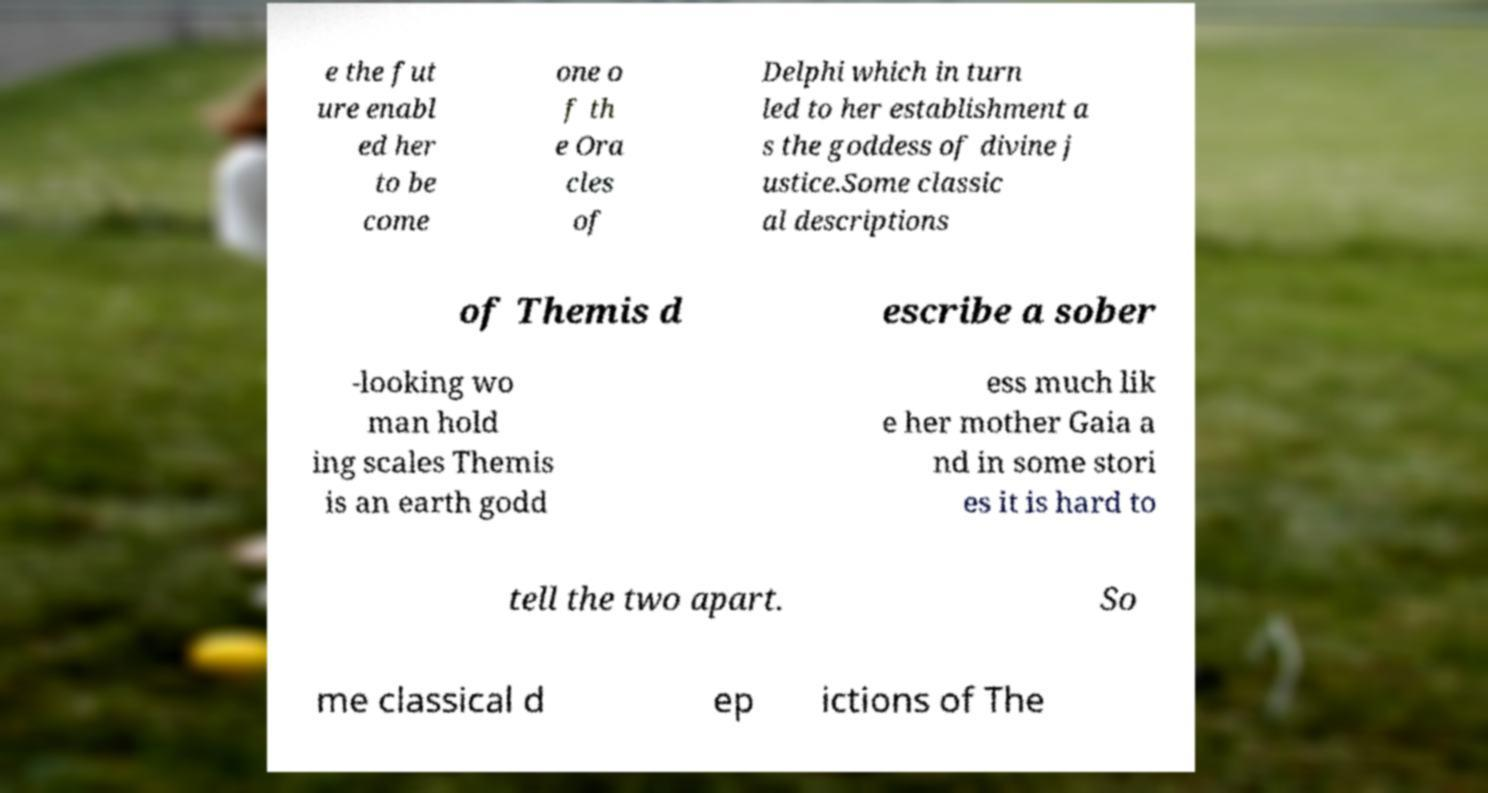What messages or text are displayed in this image? I need them in a readable, typed format. e the fut ure enabl ed her to be come one o f th e Ora cles of Delphi which in turn led to her establishment a s the goddess of divine j ustice.Some classic al descriptions of Themis d escribe a sober -looking wo man hold ing scales Themis is an earth godd ess much lik e her mother Gaia a nd in some stori es it is hard to tell the two apart. So me classical d ep ictions of The 